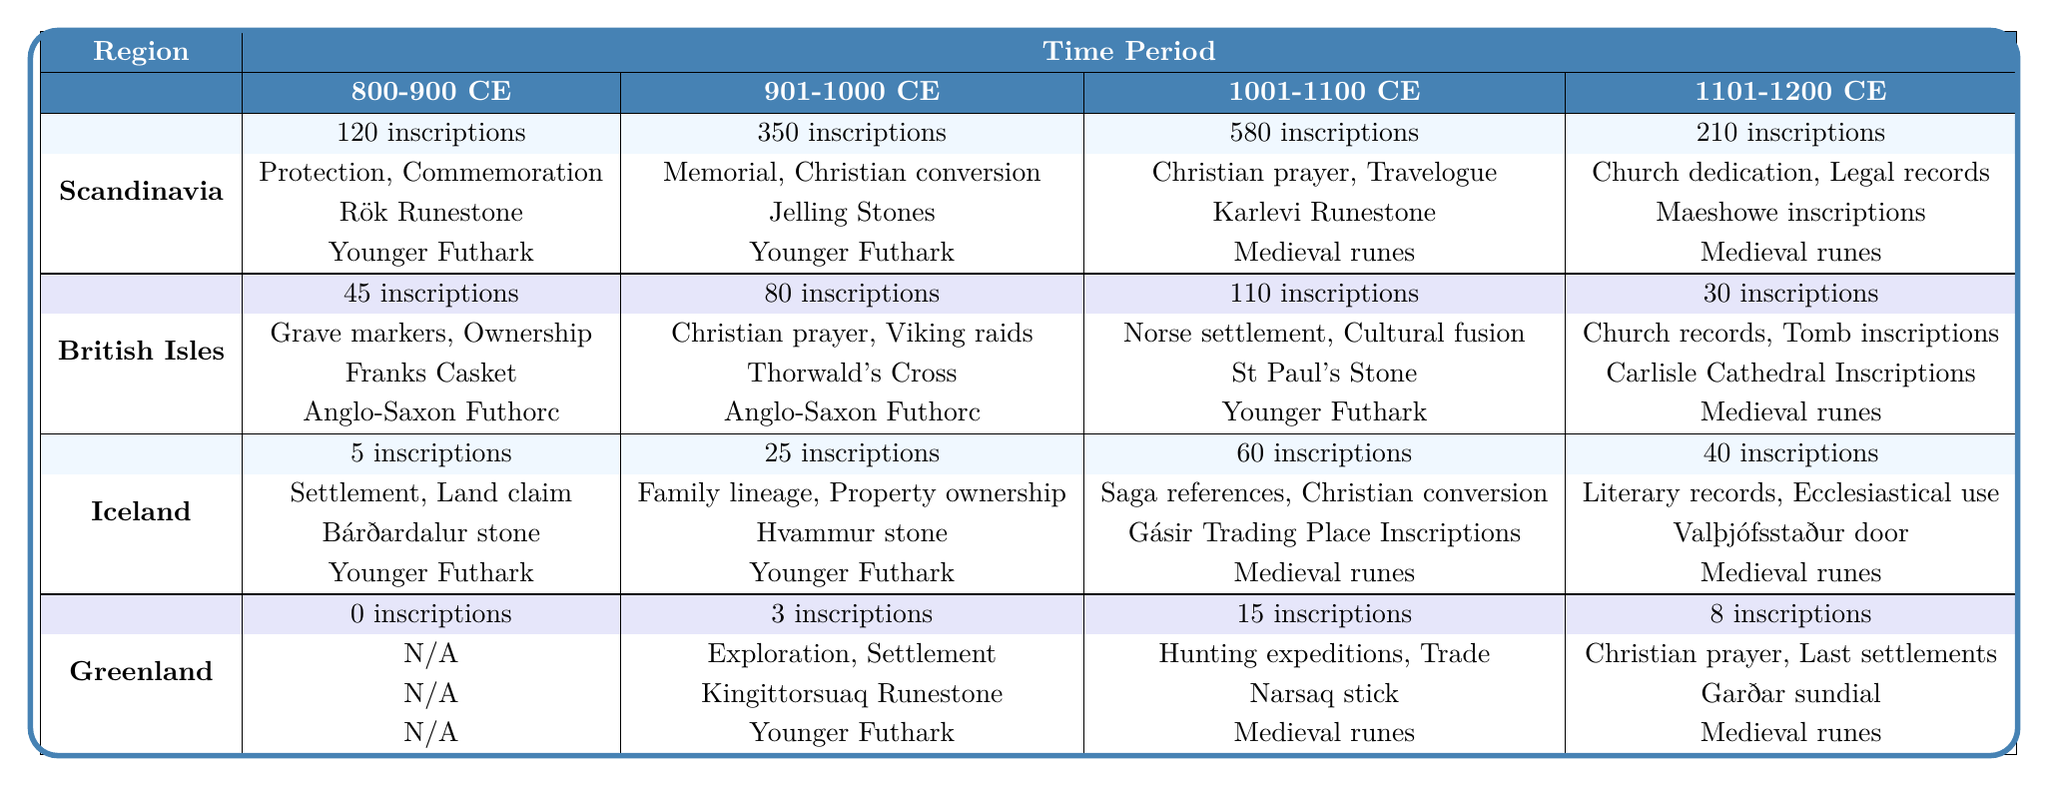What is the total number of inscriptions recorded for Scandinavia during the time period 1001-1100 CE? Looking at the table, the total number of inscriptions for Scandinavia during 1001-1100 CE is specified as 580.
Answer: 580 Which region has the most inscriptions recorded for the time period 901-1000 CE? In the table, Scandinavia shows the highest total inscriptions at 350 for the 901-1000 CE period, compared to the British Isles with 80, Iceland with 25, and Greenland with 3.
Answer: Scandinavia What are the notable artifacts listed for Iceland during the time period 1001-1100 CE? The table indicates that for Iceland in the 1001-1100 CE period, the notable artifacts are Gásir Trading Place Inscriptions and Víðimýri stone.
Answer: Gásir Trading Place Inscriptions and Víðimýri stone How many total inscriptions were recorded in Greenland from 800-900 CE to 1101-1200 CE? Adding the inscriptions from the table for Greenland: 0 (800-900) + 3 (901-1000) + 15 (1001-1100) + 8 (1101-1200) = 26.
Answer: 26 Is there any common theme present in the inscriptions for Greenland during 800-900 CE? According to the table, there are no inscriptions recorded for Greenland in the 800-900 CE period, hence no common themes are listed.
Answer: No What was the primary alphabet used for inscriptions in the British Isles during 1001-1100 CE? The table shows that the primary alphabet for the British Isles in the 1001-1100 CE time period is Younger Futhark.
Answer: Younger Futhark What is the difference in the number of inscriptions between the years 901-1000 CE and 1101-1200 CE for Scandinavia? The number of inscriptions for Scandinavia during 901-1000 CE is 350 and for 1101-1200 CE is 210. The difference is 350 - 210 = 140.
Answer: 140 Which themes are common in the inscriptions from the British Isles during 901-1000 CE? The common themes for the British Isles in 901-1000 CE, as per the table, are Christian prayer and Viking raids.
Answer: Christian prayer and Viking raids What is the trend in the total number of inscriptions for Scandinavia from 800-900 CE to 1101-1200 CE? The total inscriptions for Scandinavia over those periods are 120, 350, 580, and 210. The trend shows an increase from 800-900 CE to 1001-1100 CE, followed by a decrease in 1101-1200 CE.
Answer: Increase then decrease Which region has the least number of inscriptions recorded during the time period 800-900 CE? The table indicates that Greenland has 0 inscriptions during the 800-900 CE time period, which is the least compared to other regions.
Answer: Greenland 